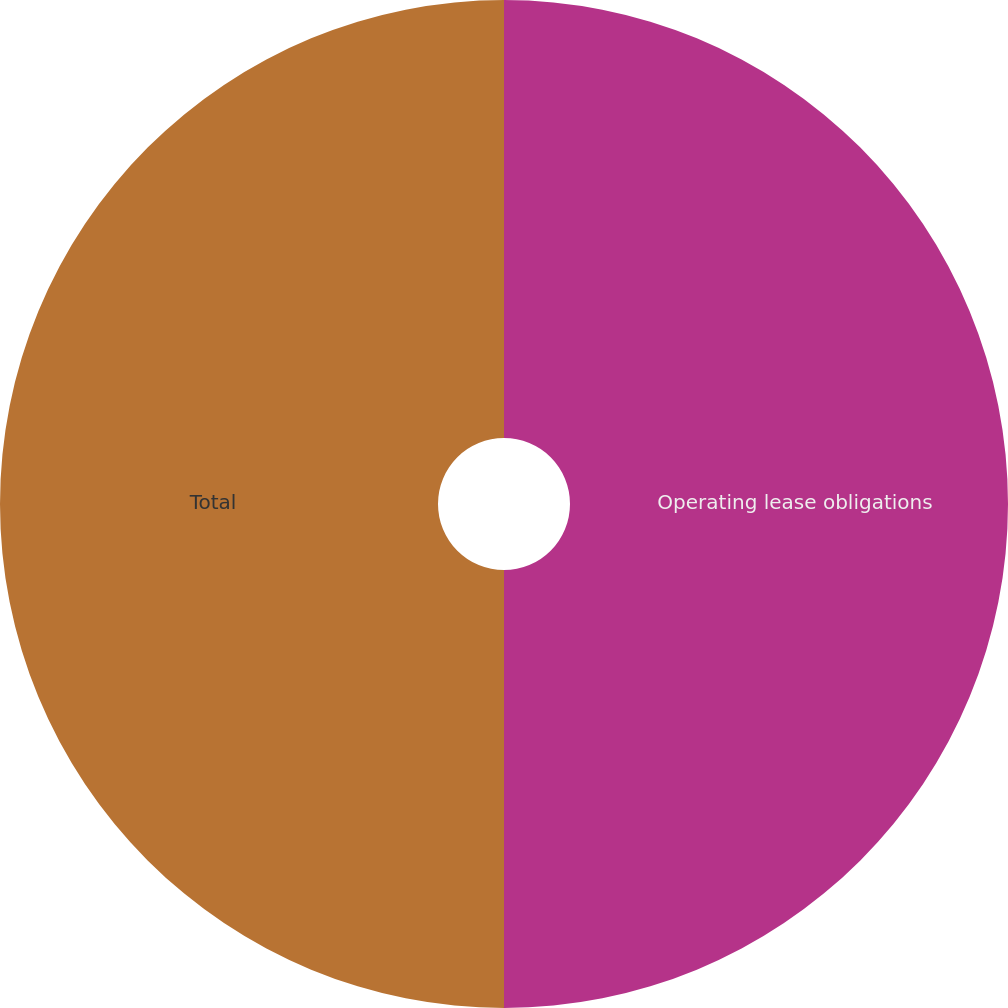Convert chart to OTSL. <chart><loc_0><loc_0><loc_500><loc_500><pie_chart><fcel>Operating lease obligations<fcel>Total<nl><fcel>50.0%<fcel>50.0%<nl></chart> 